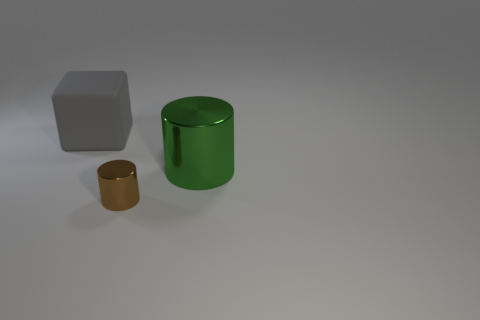Add 2 gray matte cubes. How many objects exist? 5 Subtract all green cylinders. How many cylinders are left? 1 Subtract all gray cylinders. Subtract all green balls. How many cylinders are left? 2 Subtract all cyan blocks. How many brown cylinders are left? 1 Subtract all big purple metallic cylinders. Subtract all large green cylinders. How many objects are left? 2 Add 2 tiny shiny cylinders. How many tiny shiny cylinders are left? 3 Add 1 gray cylinders. How many gray cylinders exist? 1 Subtract 1 gray cubes. How many objects are left? 2 Subtract all cubes. How many objects are left? 2 Subtract 1 cylinders. How many cylinders are left? 1 